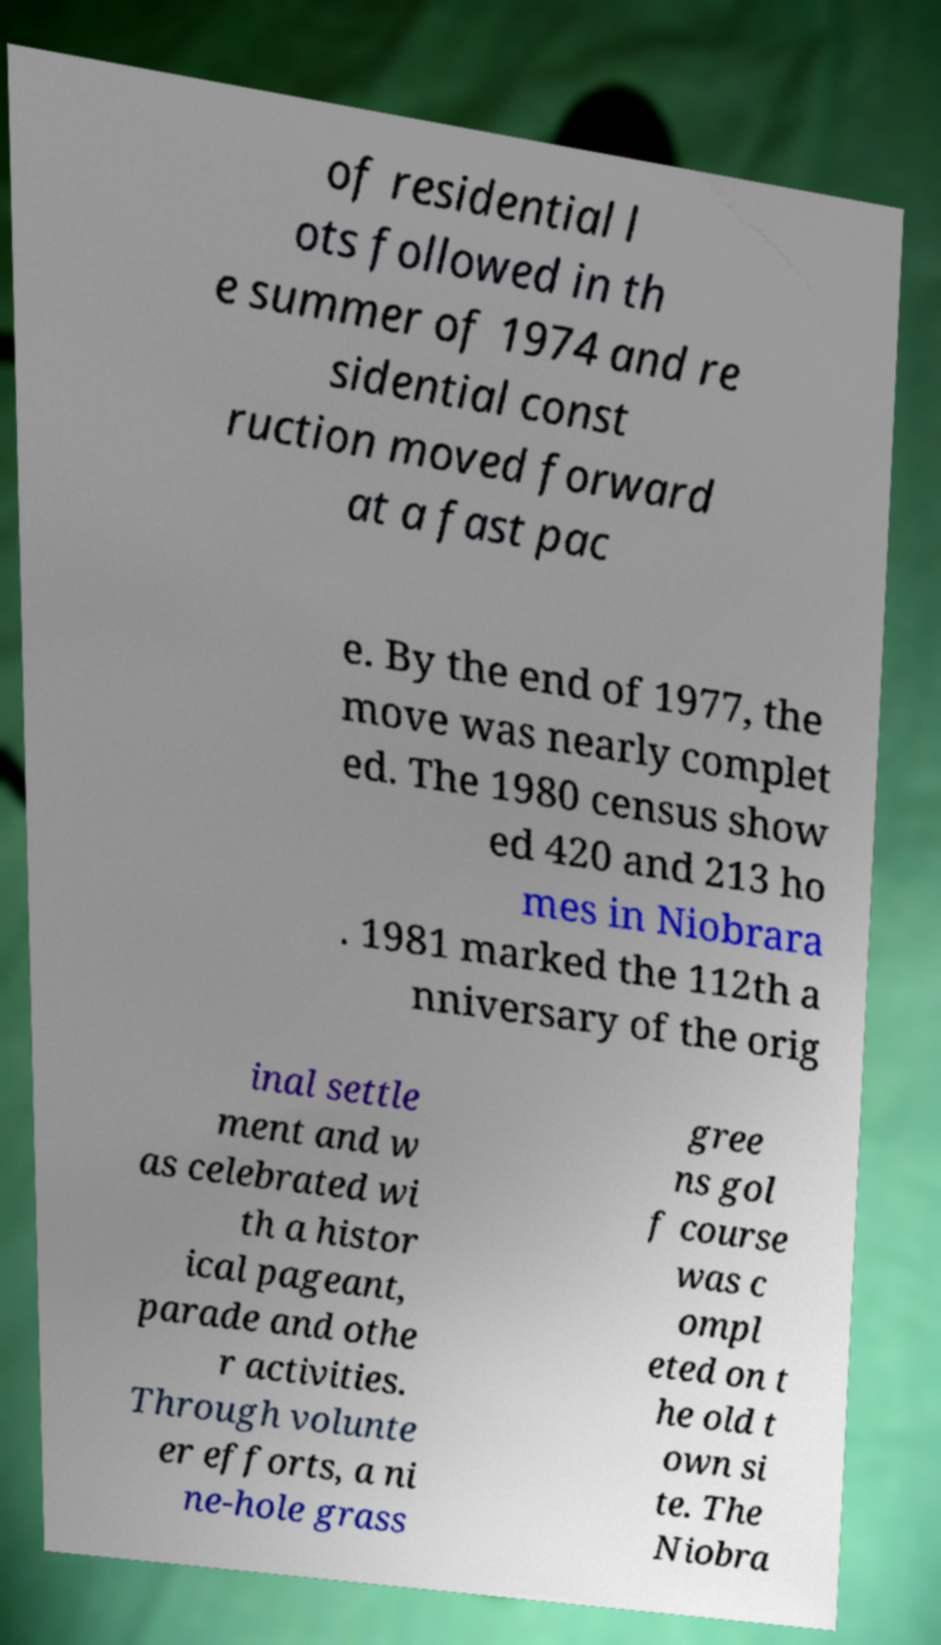Can you read and provide the text displayed in the image?This photo seems to have some interesting text. Can you extract and type it out for me? of residential l ots followed in th e summer of 1974 and re sidential const ruction moved forward at a fast pac e. By the end of 1977, the move was nearly complet ed. The 1980 census show ed 420 and 213 ho mes in Niobrara . 1981 marked the 112th a nniversary of the orig inal settle ment and w as celebrated wi th a histor ical pageant, parade and othe r activities. Through volunte er efforts, a ni ne-hole grass gree ns gol f course was c ompl eted on t he old t own si te. The Niobra 